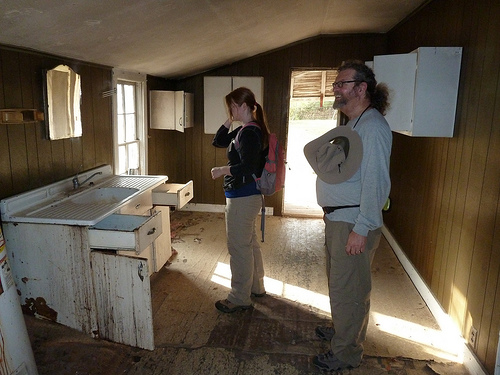<image>
Is there a electric outlet to the left of the crack? Yes. From this viewpoint, the electric outlet is positioned to the left side relative to the crack. Is there a mirror in front of the woman? Yes. The mirror is positioned in front of the woman, appearing closer to the camera viewpoint. 